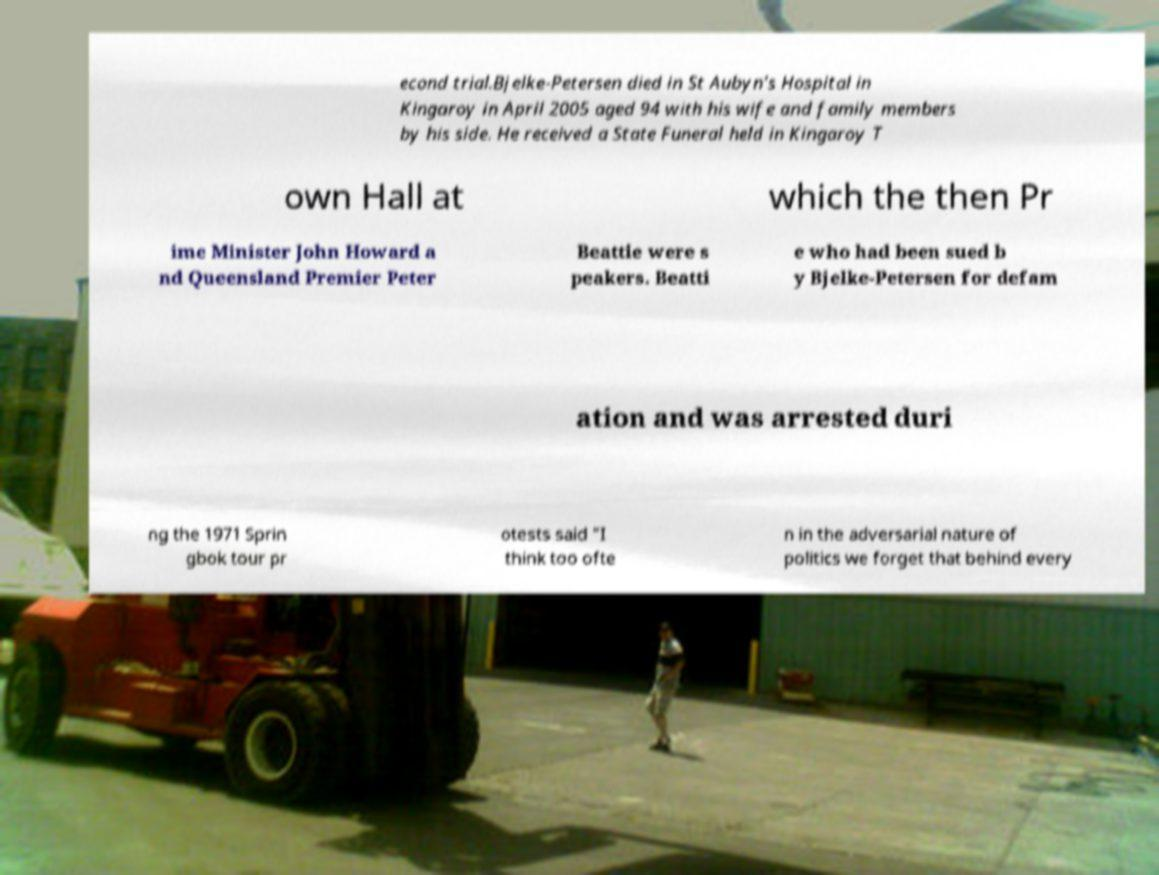Can you read and provide the text displayed in the image?This photo seems to have some interesting text. Can you extract and type it out for me? econd trial.Bjelke-Petersen died in St Aubyn's Hospital in Kingaroy in April 2005 aged 94 with his wife and family members by his side. He received a State Funeral held in Kingaroy T own Hall at which the then Pr ime Minister John Howard a nd Queensland Premier Peter Beattie were s peakers. Beatti e who had been sued b y Bjelke-Petersen for defam ation and was arrested duri ng the 1971 Sprin gbok tour pr otests said "I think too ofte n in the adversarial nature of politics we forget that behind every 